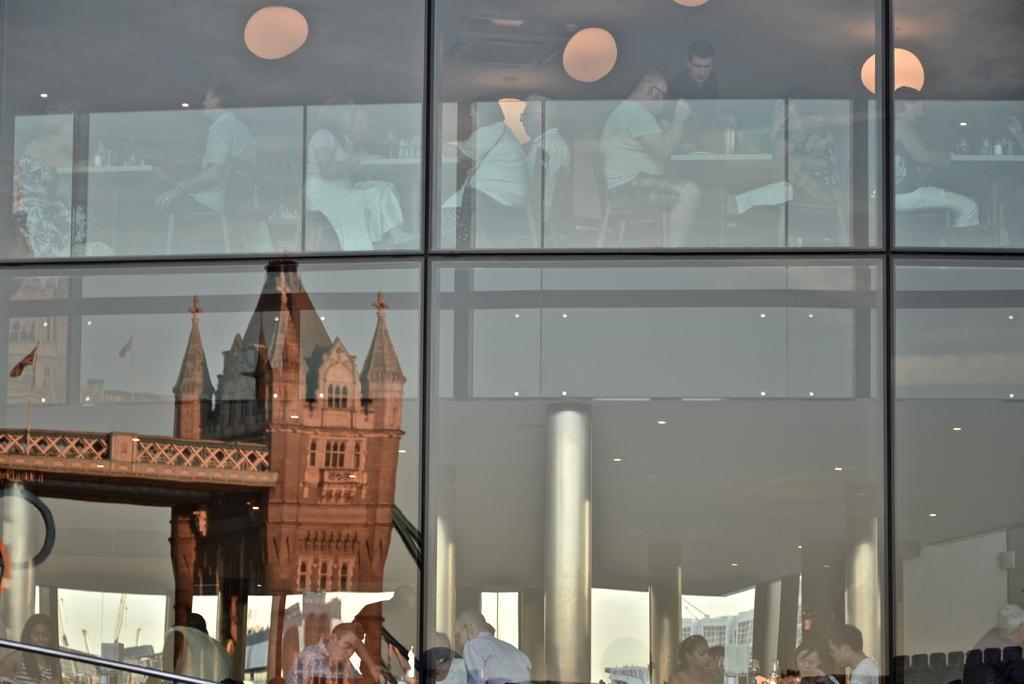Can you describe this image briefly? In this picture I can observe glass building. Inside the building I can observe some people sitting on the chairs. I can observe reflection of a bridge in the glass on the left side. 